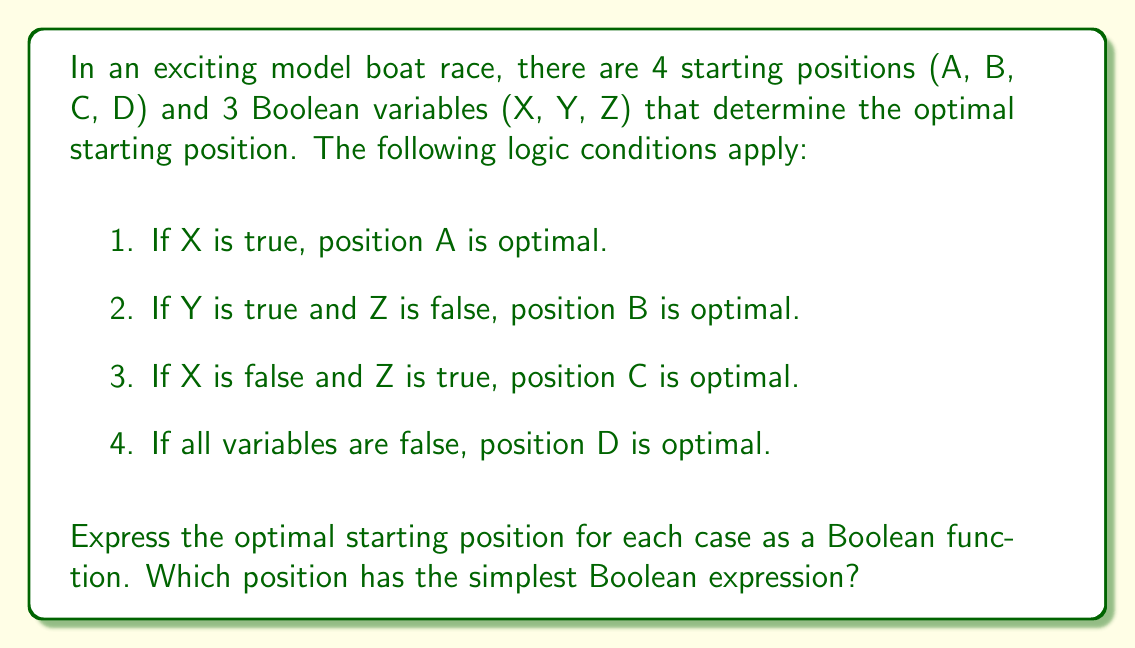Solve this math problem. Let's approach this step-by-step:

1. For position A:
   $A = X$
   This is already in its simplest form.

2. For position B:
   $B = Y \cdot \overline{Z}$
   This is the AND of Y and NOT Z.

3. For position C:
   $C = \overline{X} \cdot Z$
   This is the AND of NOT X and Z.

4. For position D:
   $D = \overline{X} \cdot \overline{Y} \cdot \overline{Z}$
   This is the AND of NOT X, NOT Y, and NOT Z.

Comparing the expressions:
- A: 1 variable
- B: 2 variables with 1 operation
- C: 2 variables with 1 operation
- D: 3 variables with 2 operations

The simplest expression is for position A, as it only involves one variable (X) without any additional operations.
Answer: Position A: $X$ 